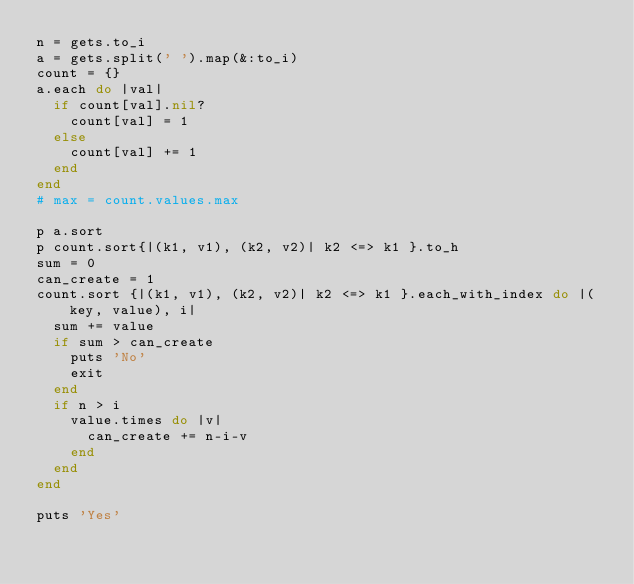Convert code to text. <code><loc_0><loc_0><loc_500><loc_500><_Ruby_>n = gets.to_i
a = gets.split(' ').map(&:to_i)
count = {}
a.each do |val|
  if count[val].nil?
    count[val] = 1
  else
    count[val] += 1
  end
end
# max = count.values.max

p a.sort
p count.sort{|(k1, v1), (k2, v2)| k2 <=> k1 }.to_h
sum = 0
can_create = 1
count.sort {|(k1, v1), (k2, v2)| k2 <=> k1 }.each_with_index do |(key, value), i|
  sum += value
  if sum > can_create
    puts 'No'
    exit
  end
  if n > i
    value.times do |v|
      can_create += n-i-v
    end
  end
end

puts 'Yes'
</code> 